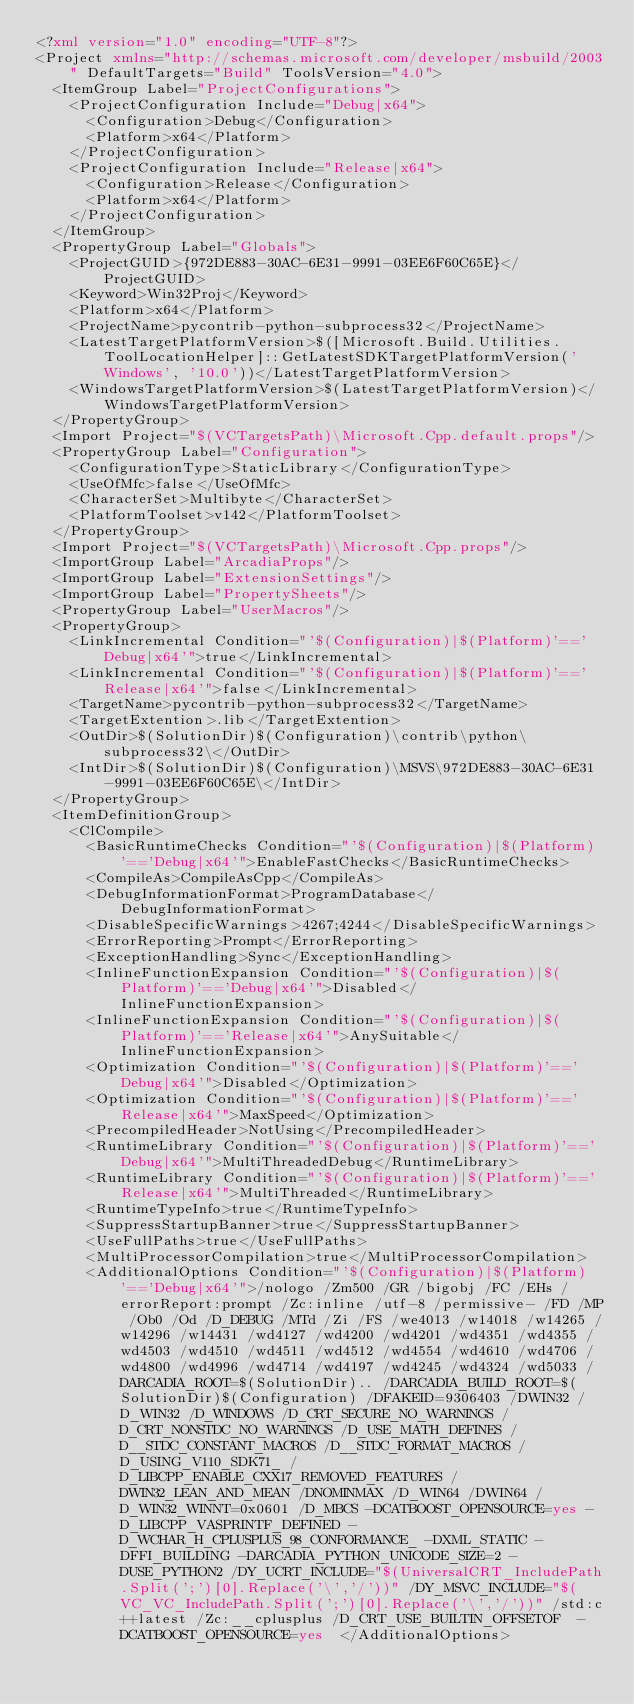Convert code to text. <code><loc_0><loc_0><loc_500><loc_500><_XML_><?xml version="1.0" encoding="UTF-8"?>
<Project xmlns="http://schemas.microsoft.com/developer/msbuild/2003" DefaultTargets="Build" ToolsVersion="4.0">
  <ItemGroup Label="ProjectConfigurations">
    <ProjectConfiguration Include="Debug|x64">
      <Configuration>Debug</Configuration>
      <Platform>x64</Platform>
    </ProjectConfiguration>
    <ProjectConfiguration Include="Release|x64">
      <Configuration>Release</Configuration>
      <Platform>x64</Platform>
    </ProjectConfiguration>
  </ItemGroup>
  <PropertyGroup Label="Globals">
    <ProjectGUID>{972DE883-30AC-6E31-9991-03EE6F60C65E}</ProjectGUID>
    <Keyword>Win32Proj</Keyword>
    <Platform>x64</Platform>
    <ProjectName>pycontrib-python-subprocess32</ProjectName>
    <LatestTargetPlatformVersion>$([Microsoft.Build.Utilities.ToolLocationHelper]::GetLatestSDKTargetPlatformVersion('Windows', '10.0'))</LatestTargetPlatformVersion>
    <WindowsTargetPlatformVersion>$(LatestTargetPlatformVersion)</WindowsTargetPlatformVersion>
  </PropertyGroup>
  <Import Project="$(VCTargetsPath)\Microsoft.Cpp.default.props"/>
  <PropertyGroup Label="Configuration">
    <ConfigurationType>StaticLibrary</ConfigurationType>
    <UseOfMfc>false</UseOfMfc>
    <CharacterSet>Multibyte</CharacterSet>
    <PlatformToolset>v142</PlatformToolset>
  </PropertyGroup>
  <Import Project="$(VCTargetsPath)\Microsoft.Cpp.props"/>
  <ImportGroup Label="ArcadiaProps"/>
  <ImportGroup Label="ExtensionSettings"/>
  <ImportGroup Label="PropertySheets"/>
  <PropertyGroup Label="UserMacros"/>
  <PropertyGroup>
    <LinkIncremental Condition="'$(Configuration)|$(Platform)'=='Debug|x64'">true</LinkIncremental>
    <LinkIncremental Condition="'$(Configuration)|$(Platform)'=='Release|x64'">false</LinkIncremental>
    <TargetName>pycontrib-python-subprocess32</TargetName>
    <TargetExtention>.lib</TargetExtention>
    <OutDir>$(SolutionDir)$(Configuration)\contrib\python\subprocess32\</OutDir>
    <IntDir>$(SolutionDir)$(Configuration)\MSVS\972DE883-30AC-6E31-9991-03EE6F60C65E\</IntDir>
  </PropertyGroup>
  <ItemDefinitionGroup>
    <ClCompile>
      <BasicRuntimeChecks Condition="'$(Configuration)|$(Platform)'=='Debug|x64'">EnableFastChecks</BasicRuntimeChecks>
      <CompileAs>CompileAsCpp</CompileAs>
      <DebugInformationFormat>ProgramDatabase</DebugInformationFormat>
      <DisableSpecificWarnings>4267;4244</DisableSpecificWarnings>
      <ErrorReporting>Prompt</ErrorReporting>
      <ExceptionHandling>Sync</ExceptionHandling>
      <InlineFunctionExpansion Condition="'$(Configuration)|$(Platform)'=='Debug|x64'">Disabled</InlineFunctionExpansion>
      <InlineFunctionExpansion Condition="'$(Configuration)|$(Platform)'=='Release|x64'">AnySuitable</InlineFunctionExpansion>
      <Optimization Condition="'$(Configuration)|$(Platform)'=='Debug|x64'">Disabled</Optimization>
      <Optimization Condition="'$(Configuration)|$(Platform)'=='Release|x64'">MaxSpeed</Optimization>
      <PrecompiledHeader>NotUsing</PrecompiledHeader>
      <RuntimeLibrary Condition="'$(Configuration)|$(Platform)'=='Debug|x64'">MultiThreadedDebug</RuntimeLibrary>
      <RuntimeLibrary Condition="'$(Configuration)|$(Platform)'=='Release|x64'">MultiThreaded</RuntimeLibrary>
      <RuntimeTypeInfo>true</RuntimeTypeInfo>
      <SuppressStartupBanner>true</SuppressStartupBanner>
      <UseFullPaths>true</UseFullPaths>
      <MultiProcessorCompilation>true</MultiProcessorCompilation>
      <AdditionalOptions Condition="'$(Configuration)|$(Platform)'=='Debug|x64'">/nologo /Zm500 /GR /bigobj /FC /EHs /errorReport:prompt /Zc:inline /utf-8 /permissive- /FD /MP /Ob0 /Od /D_DEBUG /MTd /Zi /FS /we4013 /w14018 /w14265 /w14296 /w14431 /wd4127 /wd4200 /wd4201 /wd4351 /wd4355 /wd4503 /wd4510 /wd4511 /wd4512 /wd4554 /wd4610 /wd4706 /wd4800 /wd4996 /wd4714 /wd4197 /wd4245 /wd4324 /wd5033 /DARCADIA_ROOT=$(SolutionDir).. /DARCADIA_BUILD_ROOT=$(SolutionDir)$(Configuration) /DFAKEID=9306403 /DWIN32 /D_WIN32 /D_WINDOWS /D_CRT_SECURE_NO_WARNINGS /D_CRT_NONSTDC_NO_WARNINGS /D_USE_MATH_DEFINES /D__STDC_CONSTANT_MACROS /D__STDC_FORMAT_MACROS /D_USING_V110_SDK71_ /D_LIBCPP_ENABLE_CXX17_REMOVED_FEATURES /DWIN32_LEAN_AND_MEAN /DNOMINMAX /D_WIN64 /DWIN64 /D_WIN32_WINNT=0x0601 /D_MBCS -DCATBOOST_OPENSOURCE=yes -D_LIBCPP_VASPRINTF_DEFINED -D_WCHAR_H_CPLUSPLUS_98_CONFORMANCE_ -DXML_STATIC -DFFI_BUILDING -DARCADIA_PYTHON_UNICODE_SIZE=2 -DUSE_PYTHON2 /DY_UCRT_INCLUDE="$(UniversalCRT_IncludePath.Split(';')[0].Replace('\','/'))" /DY_MSVC_INCLUDE="$(VC_VC_IncludePath.Split(';')[0].Replace('\','/'))" /std:c++latest /Zc:__cplusplus /D_CRT_USE_BUILTIN_OFFSETOF  -DCATBOOST_OPENSOURCE=yes  </AdditionalOptions></code> 